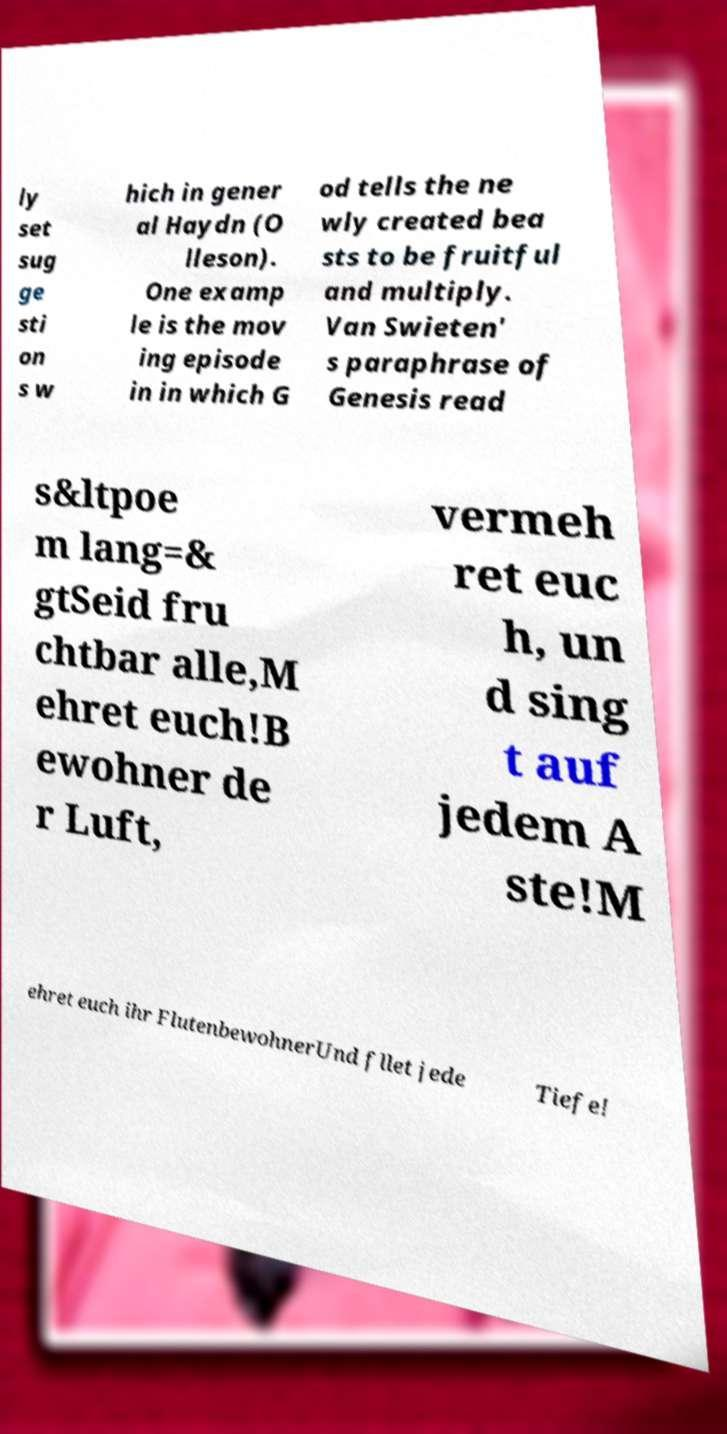I need the written content from this picture converted into text. Can you do that? ly set sug ge sti on s w hich in gener al Haydn (O lleson). One examp le is the mov ing episode in in which G od tells the ne wly created bea sts to be fruitful and multiply. Van Swieten' s paraphrase of Genesis read s&ltpoe m lang=& gtSeid fru chtbar alle,M ehret euch!B ewohner de r Luft, vermeh ret euc h, un d sing t auf jedem A ste!M ehret euch ihr FlutenbewohnerUnd fllet jede Tiefe! 